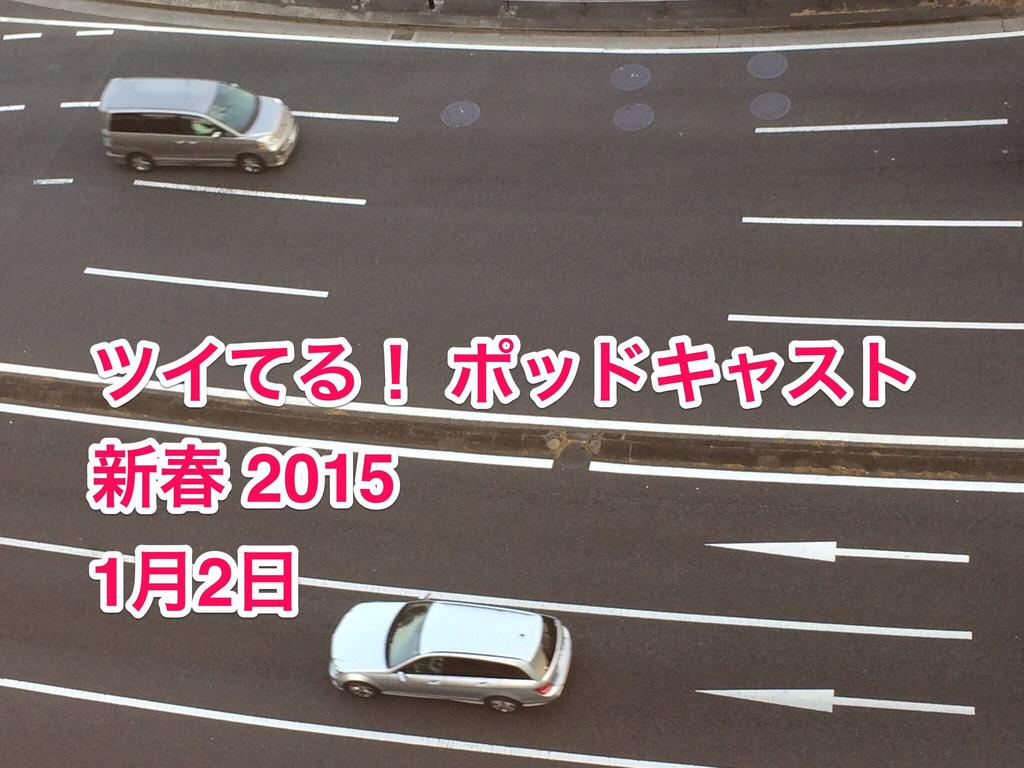How many vehicles can be seen in the image? There are two vehicles in the image. What are the vehicles doing in the image? The vehicles are moving in opposite directions. Where are the vehicles located? The vehicles are on a road. What is present in the foreground of the image? There is some text in the foreground of the image. Where is the playground located in the image? There is no playground present in the image. What type of wire can be seen connecting the two vehicles? There is no wire connecting the two vehicles in the image. 